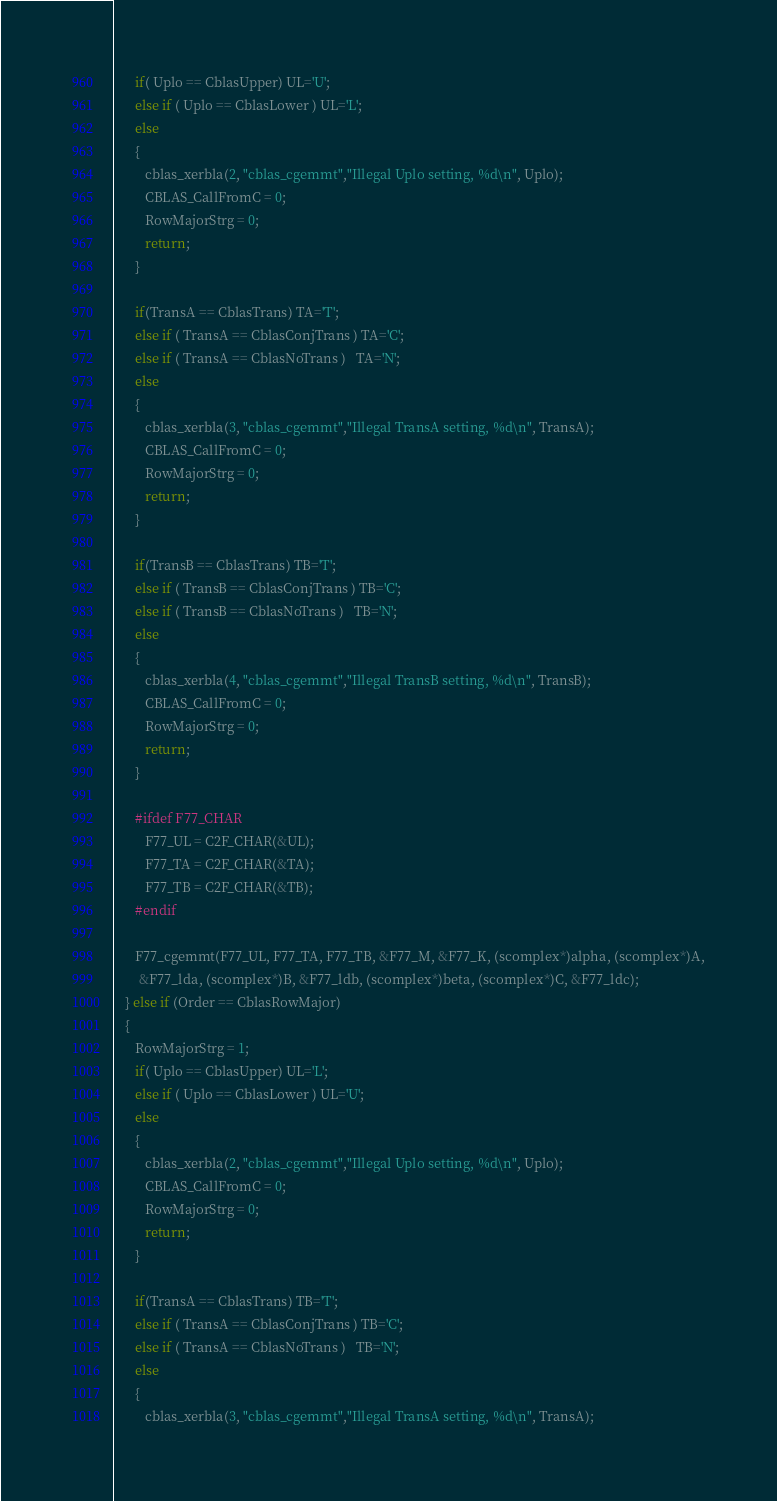Convert code to text. <code><loc_0><loc_0><loc_500><loc_500><_C_>
      if( Uplo == CblasUpper) UL='U';
      else if ( Uplo == CblasLower ) UL='L';
      else 
      {
         cblas_xerbla(2, "cblas_cgemmt","Illegal Uplo setting, %d\n", Uplo);
         CBLAS_CallFromC = 0;
         RowMajorStrg = 0;
         return;
      }

      if(TransA == CblasTrans) TA='T';
      else if ( TransA == CblasConjTrans ) TA='C';
      else if ( TransA == CblasNoTrans )   TA='N';
      else 
      {
         cblas_xerbla(3, "cblas_cgemmt","Illegal TransA setting, %d\n", TransA);
         CBLAS_CallFromC = 0;
         RowMajorStrg = 0;
         return;
      }

      if(TransB == CblasTrans) TB='T';
      else if ( TransB == CblasConjTrans ) TB='C';
      else if ( TransB == CblasNoTrans )   TB='N';
      else 
      {
         cblas_xerbla(4, "cblas_cgemmt","Illegal TransB setting, %d\n", TransB);
         CBLAS_CallFromC = 0;
         RowMajorStrg = 0;
         return;
      }

      #ifdef F77_CHAR
         F77_UL = C2F_CHAR(&UL);
         F77_TA = C2F_CHAR(&TA);
         F77_TB = C2F_CHAR(&TB);
      #endif

      F77_cgemmt(F77_UL, F77_TA, F77_TB, &F77_M, &F77_K, (scomplex*)alpha, (scomplex*)A,
       &F77_lda, (scomplex*)B, &F77_ldb, (scomplex*)beta, (scomplex*)C, &F77_ldc);
   } else if (Order == CblasRowMajor)
   {
      RowMajorStrg = 1;
      if( Uplo == CblasUpper) UL='L';
      else if ( Uplo == CblasLower ) UL='U';
      else 
      {
         cblas_xerbla(2, "cblas_cgemmt","Illegal Uplo setting, %d\n", Uplo);
         CBLAS_CallFromC = 0;
         RowMajorStrg = 0;
         return;
      }

      if(TransA == CblasTrans) TB='T';
      else if ( TransA == CblasConjTrans ) TB='C';
      else if ( TransA == CblasNoTrans )   TB='N';
      else 
      {
         cblas_xerbla(3, "cblas_cgemmt","Illegal TransA setting, %d\n", TransA);</code> 